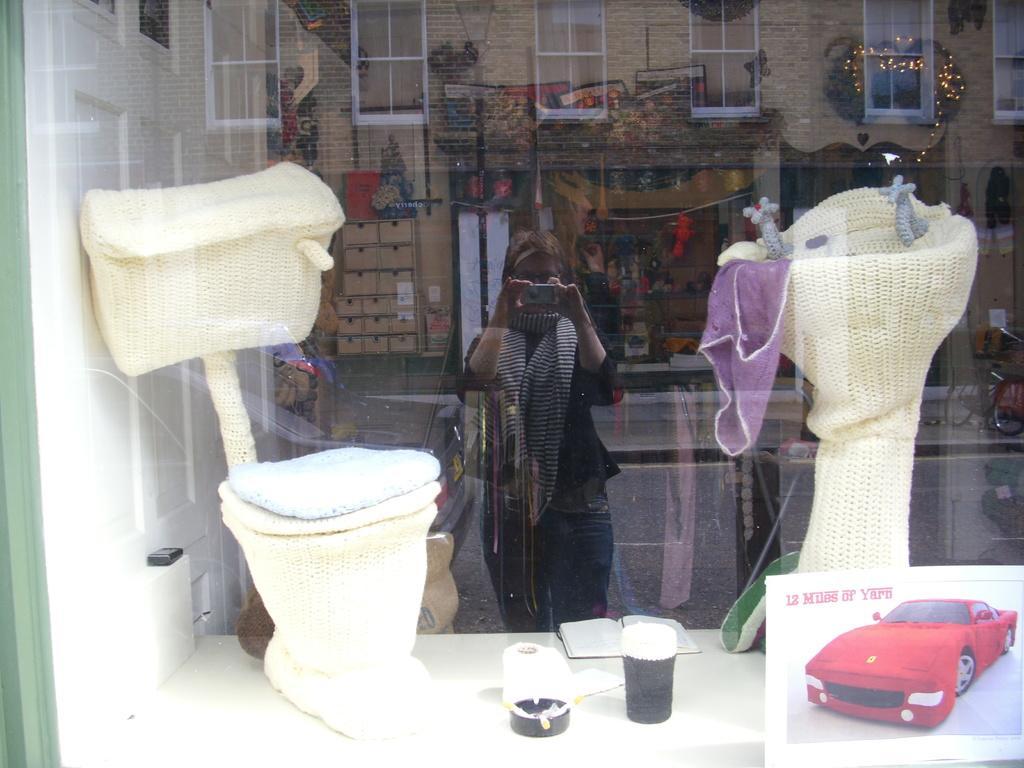Could you give a brief overview of what you see in this image? In this picture I can see wash basin, commode. In the reflection of the glass I can see the buildings. I can see a woman holding the camera. 